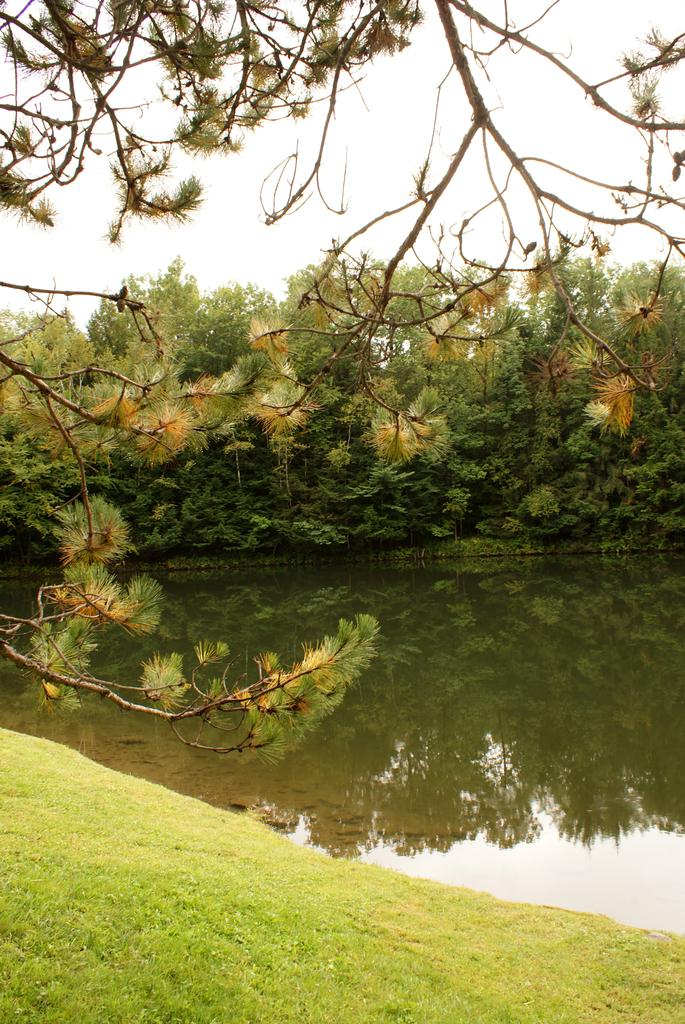What type of vegetation is on the left side of the image? There is a tree and grass on the left side of the image. What can be seen on the right side of the image? There is water on the right side of the image. What is visible in the background of the image? There are trees and the sky visible in the background of the image. Can you tell me how many fans are visible in the image? There are no fans present in the image. What type of fruit is hanging from the tree on the left side of the image? There is no fruit visible on the tree in the image. 